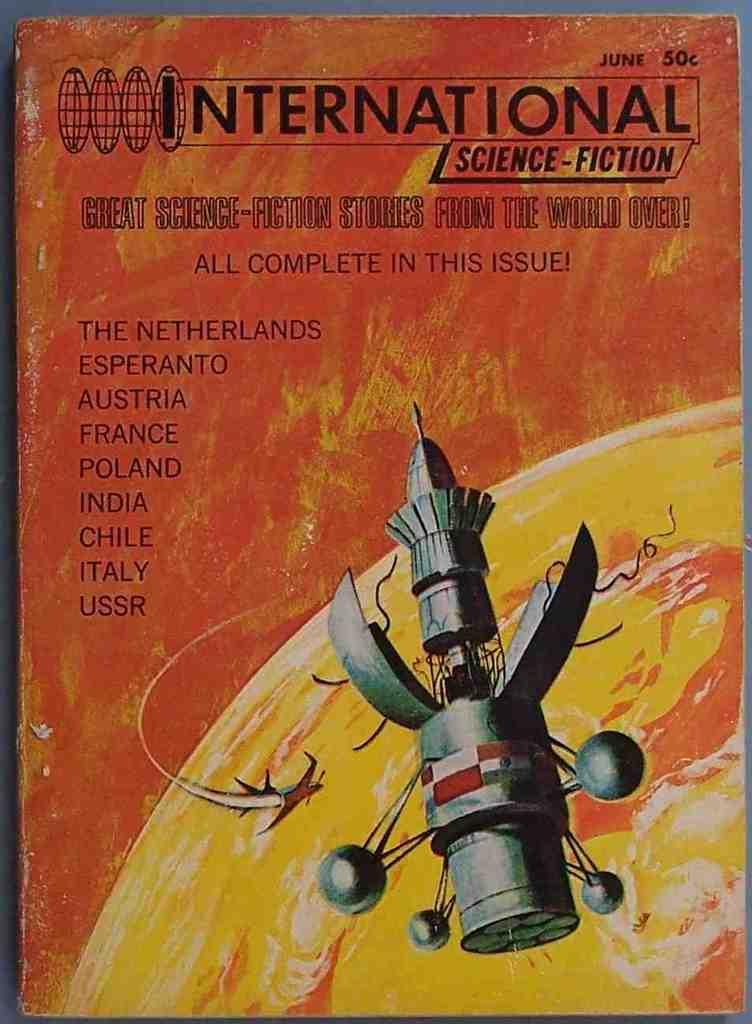<image>
Create a compact narrative representing the image presented. A poster for International Science-Fiction and a sattelite on it. 